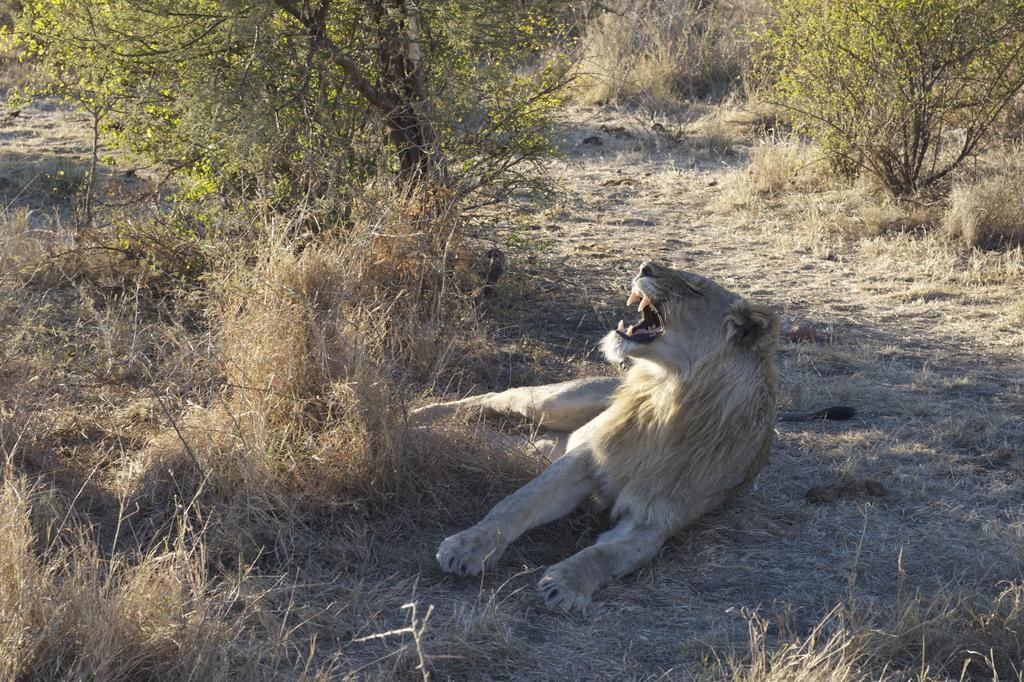What is the main subject in the center of the image? There is a lion in the center of the image. Where is the lion located in relation to the grass ground? The lion is in the center of the image, which is on an open grass ground. What type of vegetation can be seen on the grass ground? There are trees on the grass ground. What can be observed on the grass ground in addition to the trees? Shadows are visible on the grass ground. What type of rhythm can be heard in the scene with the lion? There is no sound or rhythm present in the image, as it is a still photograph. 